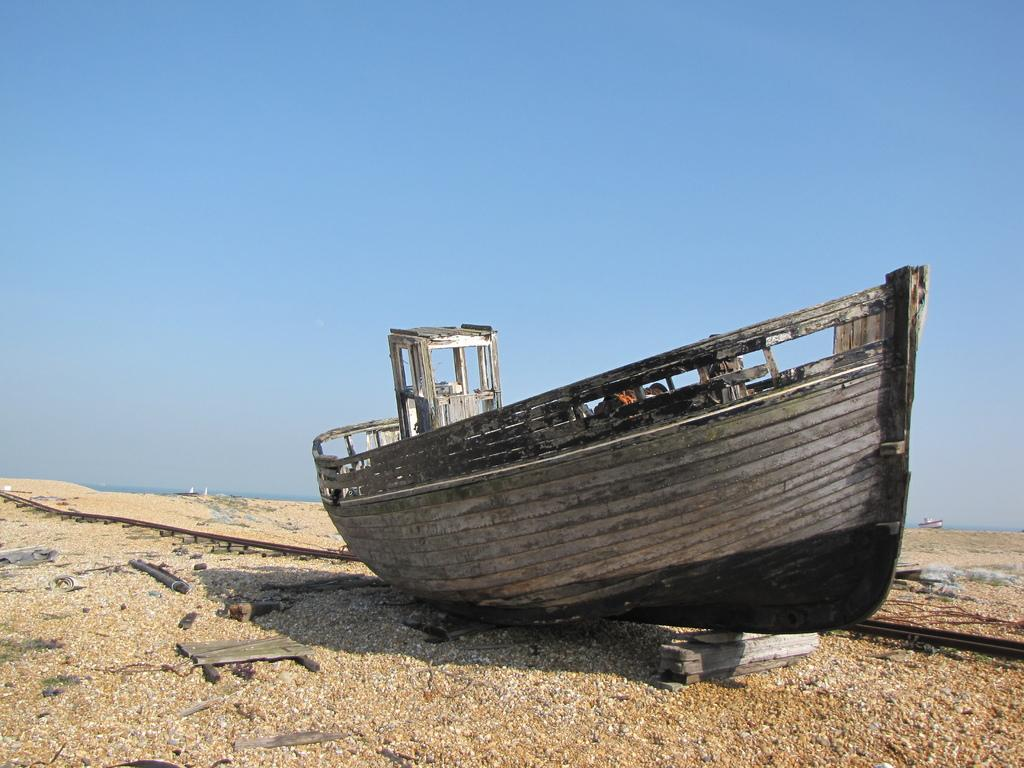What type of boat is on the ground in the image? There is a wooden boat on the ground in the image. What can be found inside the wooden boat? There are objects in the wooden boat. What is the color and type of the other boat in the image? There is a small white boat in the image. What else can be seen on the ground besides the wooden boat? There are objects on the ground. What is visible in the background of the image? The sky is visible in the background of the image. Is there a volcano erupting in the background of the image? No, there is no volcano present in the image. What type of knife is being used to cut the objects in the wooden boat? There is no knife visible in the image, and no objects are being cut. 